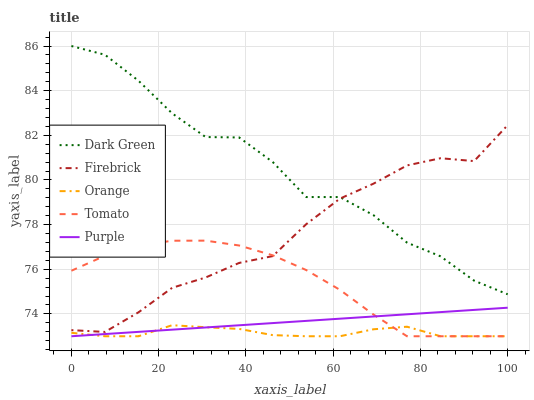Does Orange have the minimum area under the curve?
Answer yes or no. Yes. Does Dark Green have the maximum area under the curve?
Answer yes or no. Yes. Does Tomato have the minimum area under the curve?
Answer yes or no. No. Does Tomato have the maximum area under the curve?
Answer yes or no. No. Is Purple the smoothest?
Answer yes or no. Yes. Is Dark Green the roughest?
Answer yes or no. Yes. Is Tomato the smoothest?
Answer yes or no. No. Is Tomato the roughest?
Answer yes or no. No. Does Orange have the lowest value?
Answer yes or no. Yes. Does Firebrick have the lowest value?
Answer yes or no. No. Does Dark Green have the highest value?
Answer yes or no. Yes. Does Tomato have the highest value?
Answer yes or no. No. Is Purple less than Firebrick?
Answer yes or no. Yes. Is Firebrick greater than Purple?
Answer yes or no. Yes. Does Purple intersect Orange?
Answer yes or no. Yes. Is Purple less than Orange?
Answer yes or no. No. Is Purple greater than Orange?
Answer yes or no. No. Does Purple intersect Firebrick?
Answer yes or no. No. 